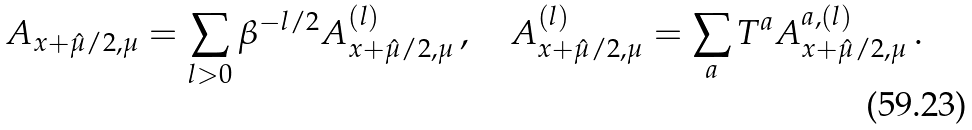<formula> <loc_0><loc_0><loc_500><loc_500>A _ { x + \hat { \mu } / { 2 } , \mu } = \sum _ { l > 0 } \beta ^ { - l / 2 } A ^ { ( l ) } _ { x + \hat { \mu } / { 2 } , \mu } \, , \quad A ^ { ( l ) } _ { x + \hat { \mu } / { 2 } , \mu } = \sum _ { a } T ^ { a } A ^ { a , ( l ) } _ { x + \hat { \mu } / { 2 } , \mu } \, .</formula> 